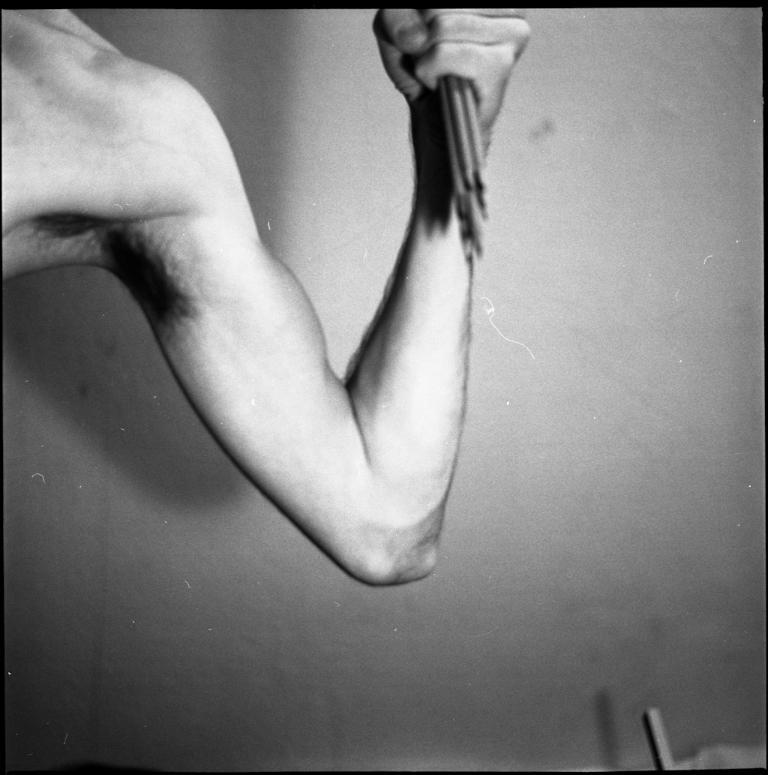What part of a person's body is visible in the image? There is a person's hand in the image. What can be seen behind the hand in the image? There is a wall in the background of the image. What type of insurance policy is being discussed in the image? There is no discussion or reference to insurance in the image; it only shows a person's hand and a wall in the background. 